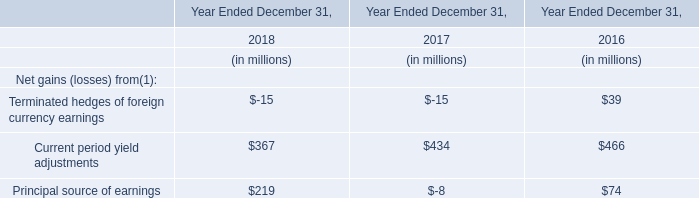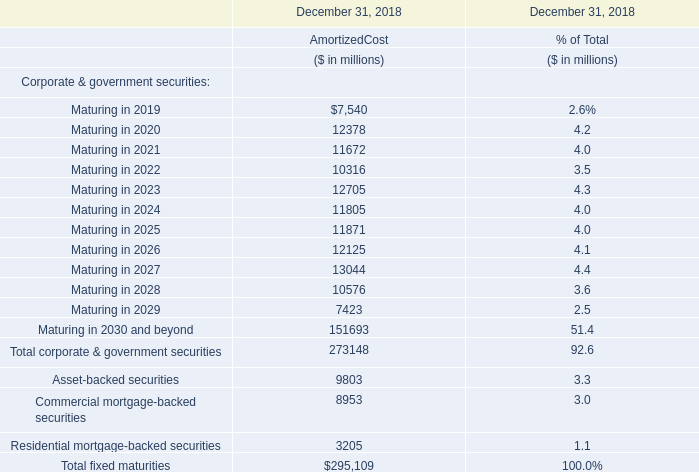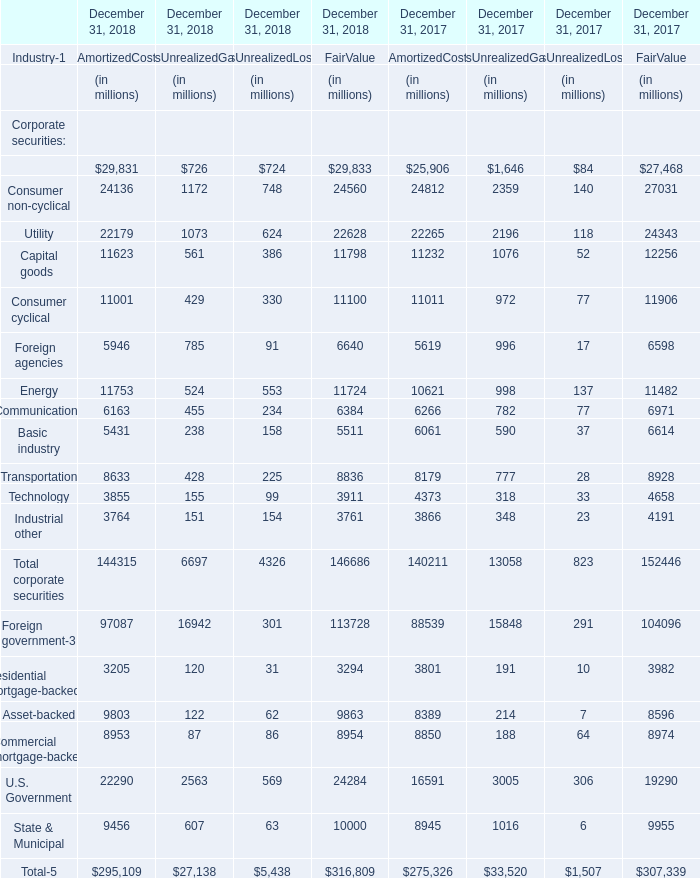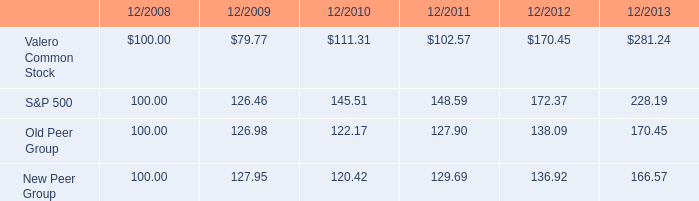Which year has the greatest proportion of AmortizedCost ? 
Answer: 2027. 